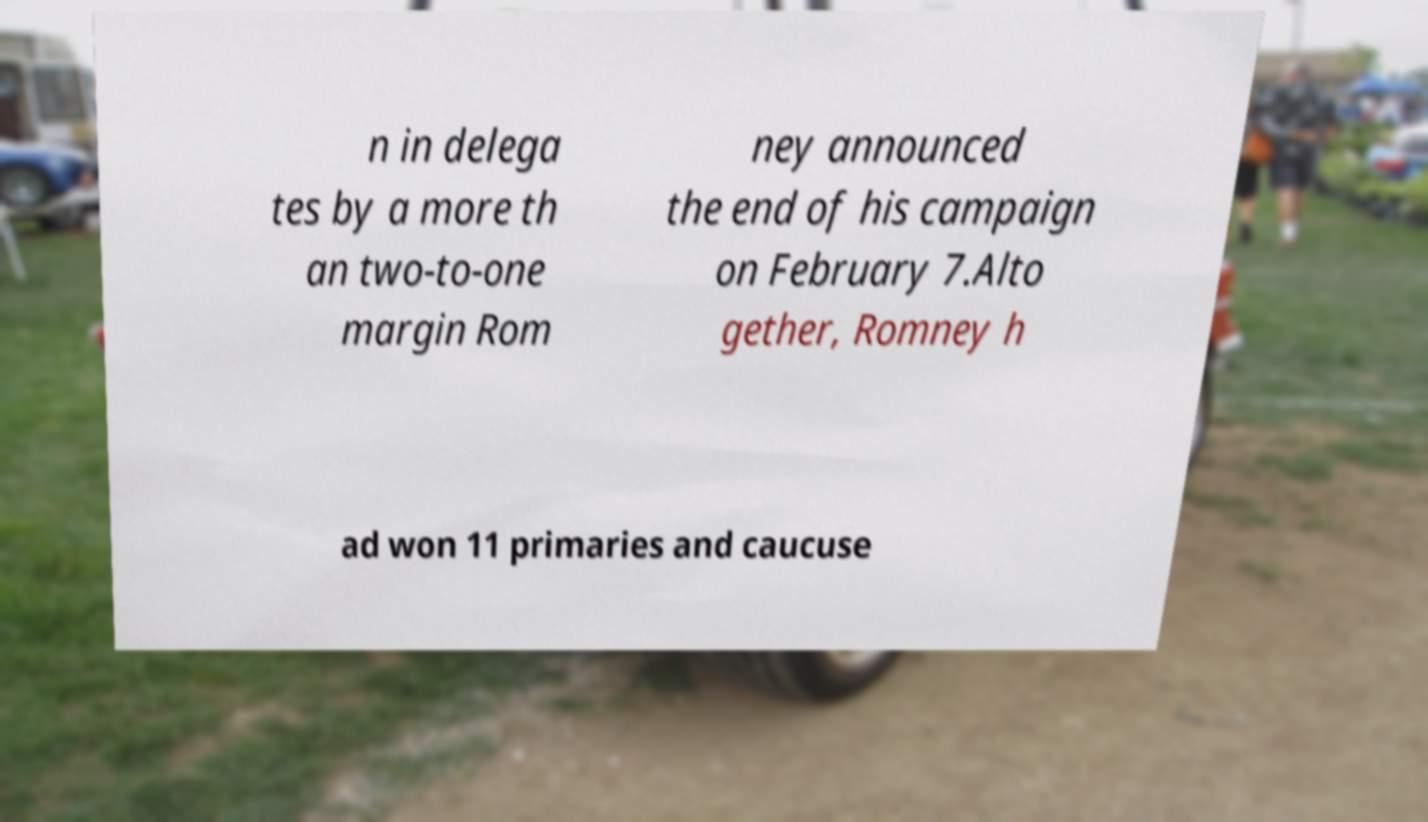Could you extract and type out the text from this image? n in delega tes by a more th an two-to-one margin Rom ney announced the end of his campaign on February 7.Alto gether, Romney h ad won 11 primaries and caucuse 